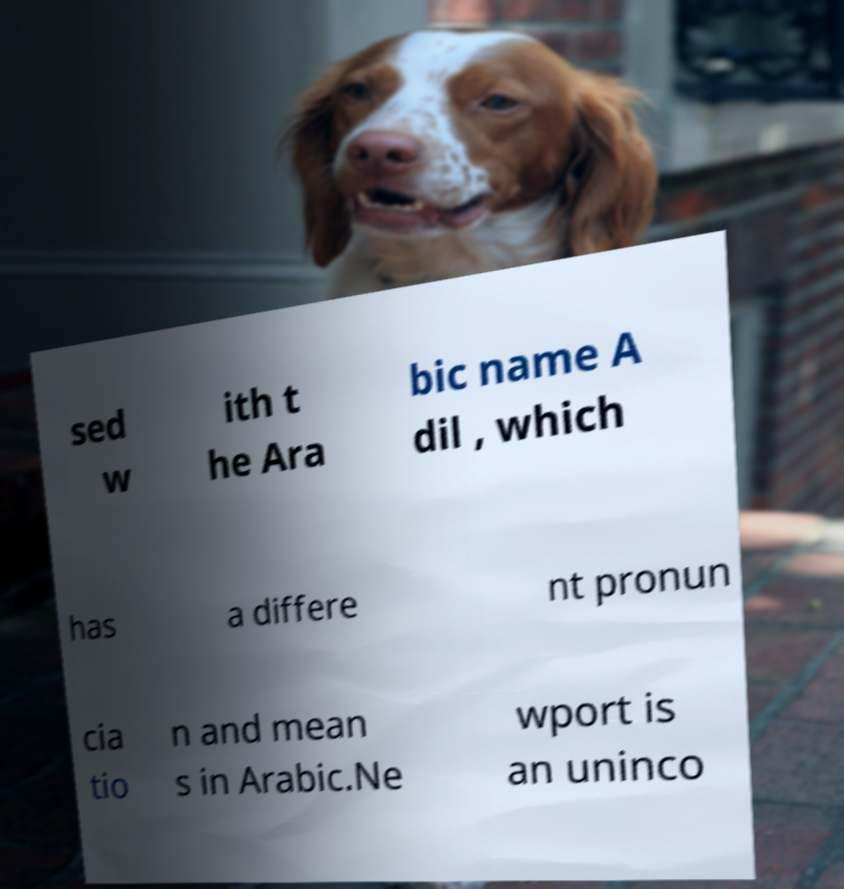For documentation purposes, I need the text within this image transcribed. Could you provide that? sed w ith t he Ara bic name A dil , which has a differe nt pronun cia tio n and mean s in Arabic.Ne wport is an uninco 